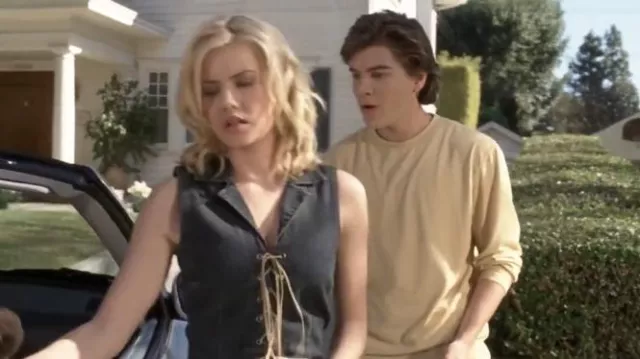What specific emotions can you identify from their facial expressions and body language? The woman in the foreground appears to be experiencing strong emotions, likely frustration or anger, as suggested by her furrowed brows, slightly pursed lips, and the act of walking away with a determined stride. Her partially turned back indicates a desire to distance herself from the situation. The young man, in contrast, displays concern and hesitation, as seen through his wide eyes and slightly open mouth, which could indicate he's in the midst of speaking or is caught off-guard by her reaction. Imagine that these characters are involved in a science fiction storyline. What could be happening? In a science fiction storyline, the scene could represent a crucial moment in the plot where these characters, who might be space travelers or part of a future society, face a moral or ethical dilemma. The woman could be a high-ranking officer who has just discovered the truth about a mission that endangers innocent lives. She is distraught and considering abandoning her duty to prevent disaster. The young man could be her second-in-command, realizing the gravity of her decision but conflicted about the repercussions of their actions. The car could be a form of advanced transportation, hinting at an escape or a covert operation that's about to commence. 